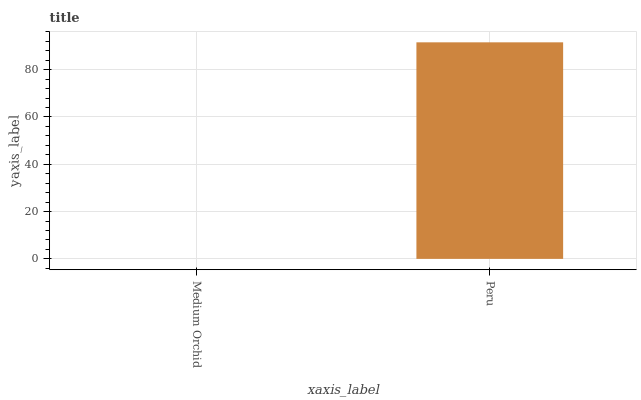Is Medium Orchid the minimum?
Answer yes or no. Yes. Is Peru the maximum?
Answer yes or no. Yes. Is Peru the minimum?
Answer yes or no. No. Is Peru greater than Medium Orchid?
Answer yes or no. Yes. Is Medium Orchid less than Peru?
Answer yes or no. Yes. Is Medium Orchid greater than Peru?
Answer yes or no. No. Is Peru less than Medium Orchid?
Answer yes or no. No. Is Peru the high median?
Answer yes or no. Yes. Is Medium Orchid the low median?
Answer yes or no. Yes. Is Medium Orchid the high median?
Answer yes or no. No. Is Peru the low median?
Answer yes or no. No. 